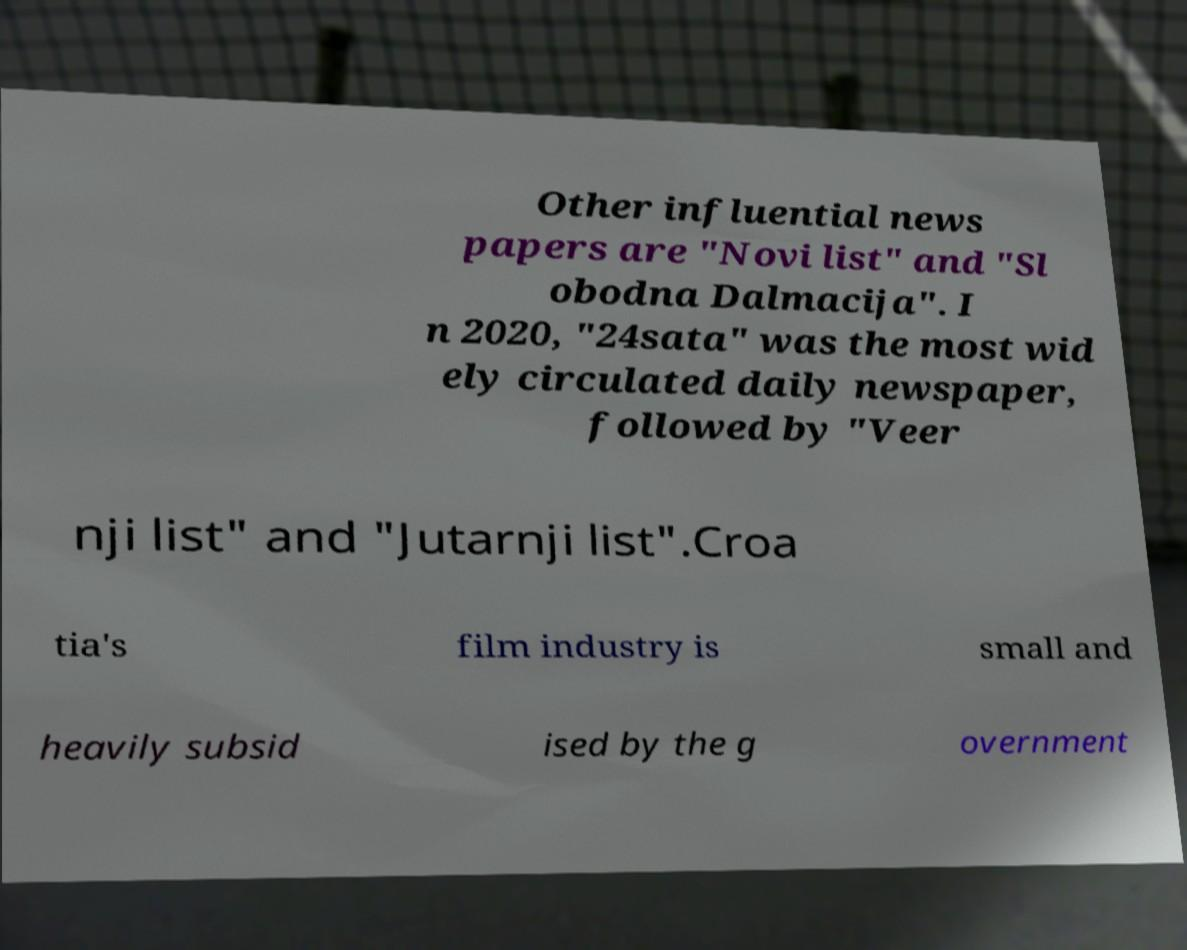Could you assist in decoding the text presented in this image and type it out clearly? Other influential news papers are "Novi list" and "Sl obodna Dalmacija". I n 2020, "24sata" was the most wid ely circulated daily newspaper, followed by "Veer nji list" and "Jutarnji list".Croa tia's film industry is small and heavily subsid ised by the g overnment 